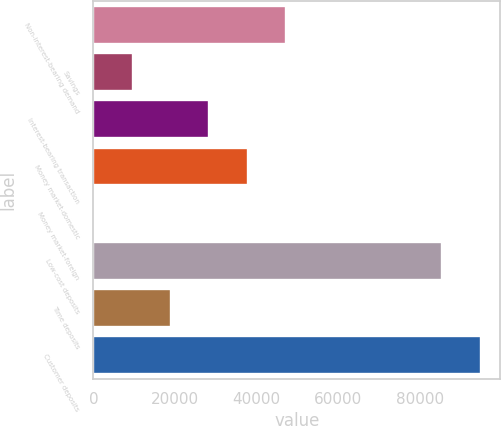Convert chart to OTSL. <chart><loc_0><loc_0><loc_500><loc_500><bar_chart><fcel>Non-interest-bearing demand<fcel>Savings<fcel>Interest-bearing transaction<fcel>Money market-domestic<fcel>Money market-foreign<fcel>Low-cost deposits<fcel>Time deposits<fcel>Customer deposits<nl><fcel>47232.5<fcel>9658.5<fcel>28445.5<fcel>37839<fcel>265<fcel>85605<fcel>19052<fcel>94998.5<nl></chart> 